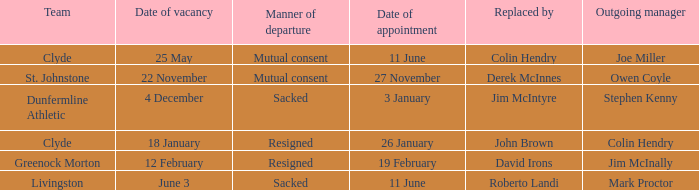Name the manner of departyre for 26 january date of appointment Resigned. 